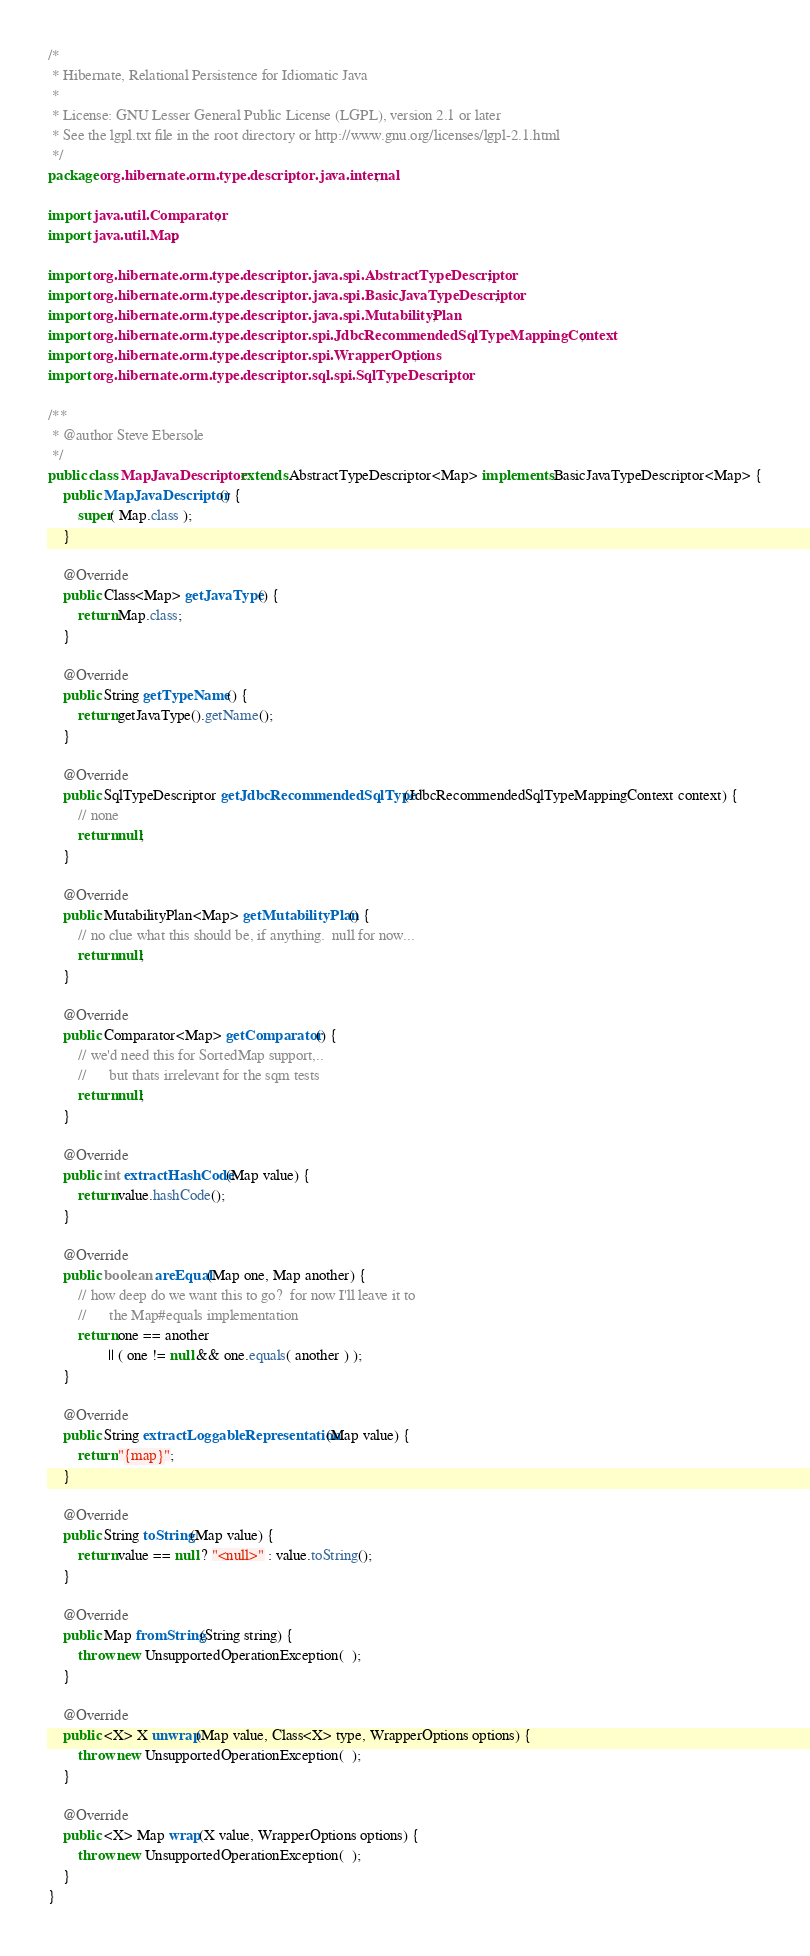<code> <loc_0><loc_0><loc_500><loc_500><_Java_>/*
 * Hibernate, Relational Persistence for Idiomatic Java
 *
 * License: GNU Lesser General Public License (LGPL), version 2.1 or later
 * See the lgpl.txt file in the root directory or http://www.gnu.org/licenses/lgpl-2.1.html
 */
package org.hibernate.orm.type.descriptor.java.internal;

import java.util.Comparator;
import java.util.Map;

import org.hibernate.orm.type.descriptor.java.spi.AbstractTypeDescriptor;
import org.hibernate.orm.type.descriptor.java.spi.BasicJavaTypeDescriptor;
import org.hibernate.orm.type.descriptor.java.spi.MutabilityPlan;
import org.hibernate.orm.type.descriptor.spi.JdbcRecommendedSqlTypeMappingContext;
import org.hibernate.orm.type.descriptor.spi.WrapperOptions;
import org.hibernate.orm.type.descriptor.sql.spi.SqlTypeDescriptor;

/**
 * @author Steve Ebersole
 */
public class MapJavaDescriptor extends AbstractTypeDescriptor<Map> implements BasicJavaTypeDescriptor<Map> {
	public MapJavaDescriptor() {
		super( Map.class );
	}

	@Override
	public Class<Map> getJavaType() {
		return Map.class;
	}

	@Override
	public String getTypeName() {
		return getJavaType().getName();
	}

	@Override
	public SqlTypeDescriptor getJdbcRecommendedSqlType(JdbcRecommendedSqlTypeMappingContext context) {
		// none
		return null;
	}

	@Override
	public MutabilityPlan<Map> getMutabilityPlan() {
		// no clue what this should be, if anything.  null for now...
		return null;
	}

	@Override
	public Comparator<Map> getComparator() {
		// we'd need this for SortedMap support,..
		//		but thats irrelevant for the sqm tests
		return null;
	}

	@Override
	public int extractHashCode(Map value) {
		return value.hashCode();
	}

	@Override
	public boolean areEqual(Map one, Map another) {
		// how deep do we want this to go?  for now I'll leave it to
		//		the Map#equals implementation
		return one == another
				|| ( one != null && one.equals( another ) );
	}

	@Override
	public String extractLoggableRepresentation(Map value) {
		return "{map}";
	}

	@Override
	public String toString(Map value) {
		return value == null ? "<null>" : value.toString();
	}

	@Override
	public Map fromString(String string) {
		throw new UnsupportedOperationException(  );
	}

	@Override
	public <X> X unwrap(Map value, Class<X> type, WrapperOptions options) {
		throw new UnsupportedOperationException(  );
	}

	@Override
	public <X> Map wrap(X value, WrapperOptions options) {
		throw new UnsupportedOperationException(  );
	}
}
</code> 